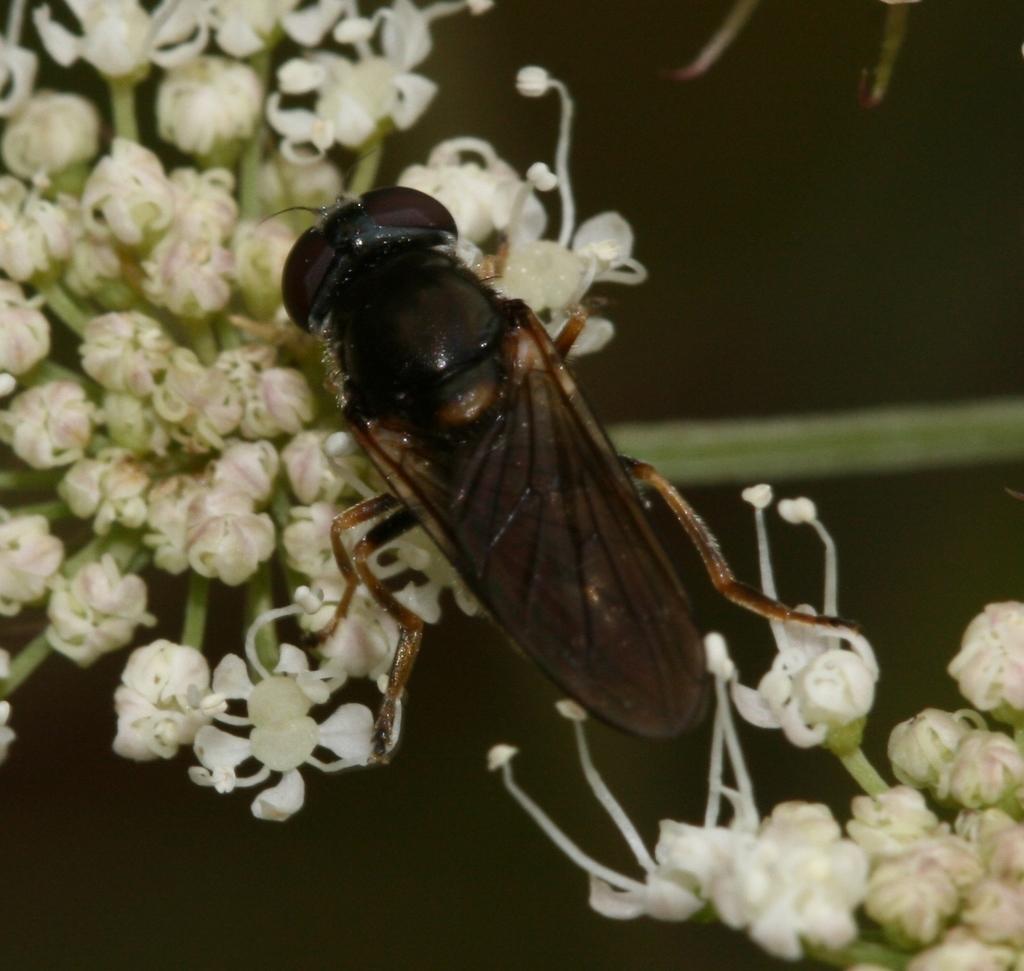How would you summarize this image in a sentence or two? In this image in the center there is one insect on the flowers, and there is a blurry background. 